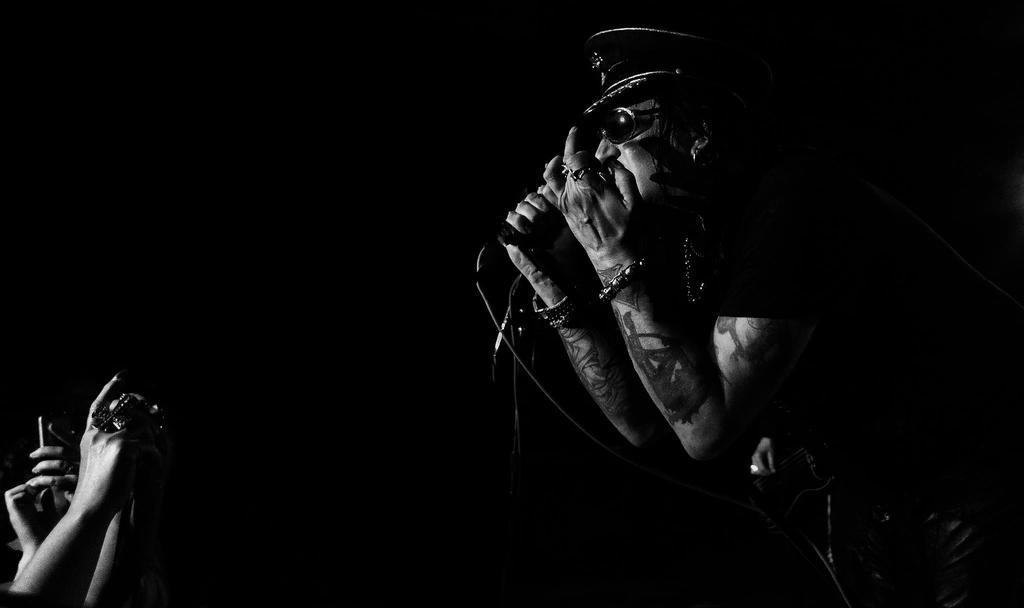What is the color scheme of the image? The image is black and white. What is the man in the image doing? The man is standing and holding a microphone. Where are the people located in the image? The people are at the bottom left of the image. What are the people doing in the image? The people are clicking photographs. What type of pies can be seen in the image? There are no pies present in the image. What is the name of the person holding the microphone in the image? The provided facts do not include the name of the person holding the microphone. 